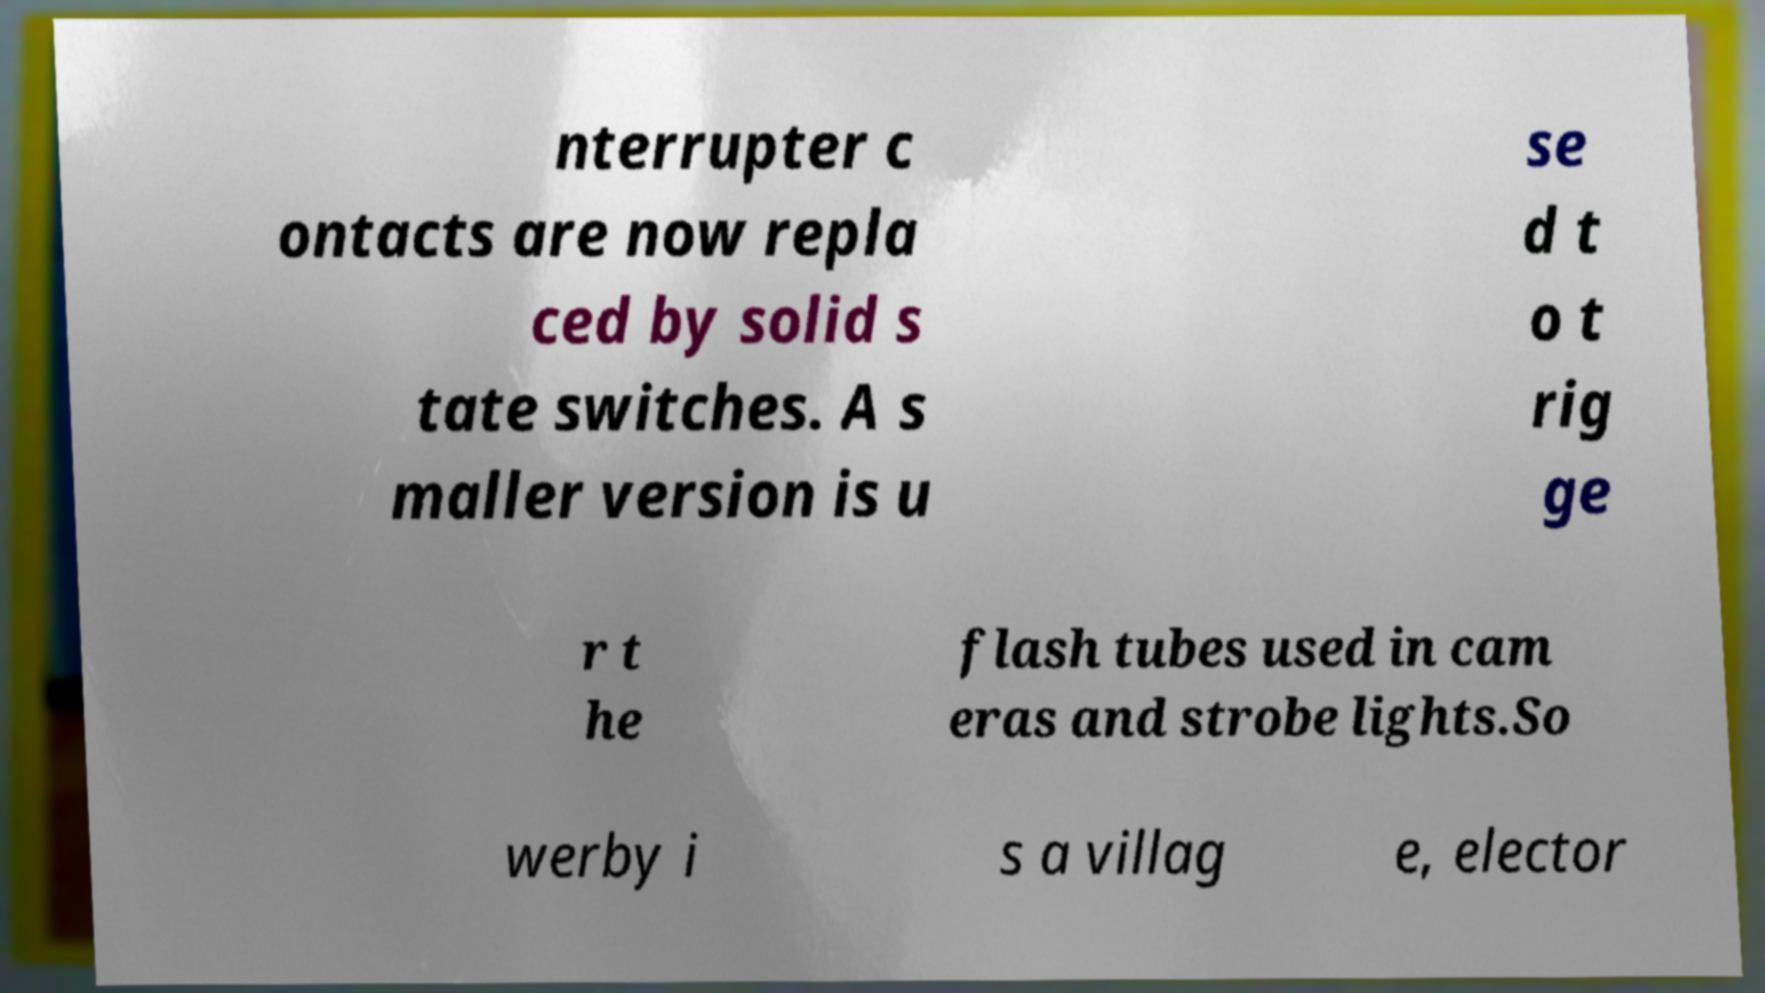Can you accurately transcribe the text from the provided image for me? nterrupter c ontacts are now repla ced by solid s tate switches. A s maller version is u se d t o t rig ge r t he flash tubes used in cam eras and strobe lights.So werby i s a villag e, elector 